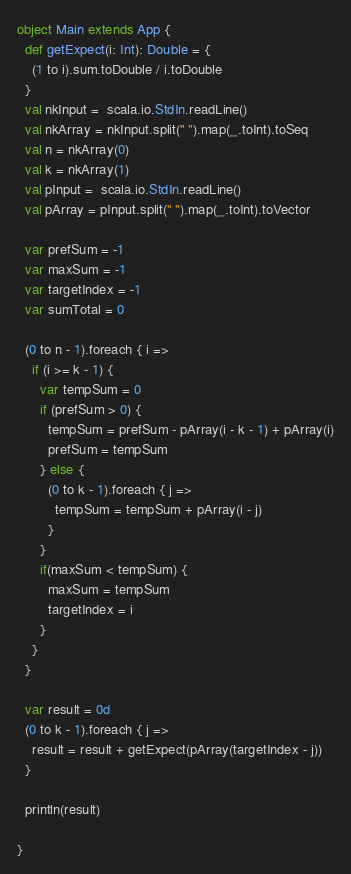Convert code to text. <code><loc_0><loc_0><loc_500><loc_500><_Scala_>object Main extends App {
  def getExpect(i: Int): Double = {
    (1 to i).sum.toDouble / i.toDouble
  }
  val nkInput =  scala.io.StdIn.readLine()
  val nkArray = nkInput.split(" ").map(_.toInt).toSeq
  val n = nkArray(0)
  val k = nkArray(1)
  val pInput =  scala.io.StdIn.readLine()
  val pArray = pInput.split(" ").map(_.toInt).toVector

  var prefSum = -1
  var maxSum = -1
  var targetIndex = -1
  var sumTotal = 0

  (0 to n - 1).foreach { i =>
    if (i >= k - 1) {
      var tempSum = 0
      if (prefSum > 0) {
        tempSum = prefSum - pArray(i - k - 1) + pArray(i)
        prefSum = tempSum
      } else {
        (0 to k - 1).foreach { j =>
          tempSum = tempSum + pArray(i - j)
        }
      }
      if(maxSum < tempSum) {
        maxSum = tempSum
        targetIndex = i
      }
    }
  }

  var result = 0d
  (0 to k - 1).foreach { j =>
    result = result + getExpect(pArray(targetIndex - j))
  }

  println(result)

}</code> 